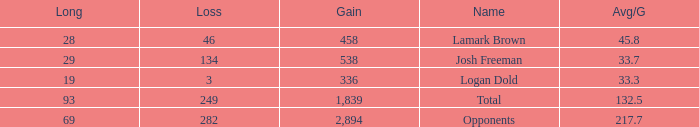How much Gain has a Long of 29, and an Avg/G smaller than 33.7? 0.0. 